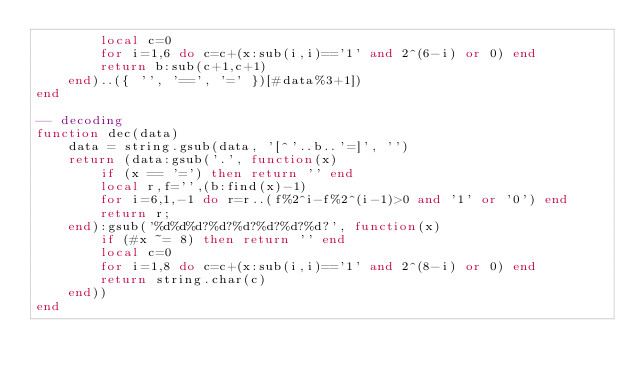<code> <loc_0><loc_0><loc_500><loc_500><_Lua_>        local c=0
        for i=1,6 do c=c+(x:sub(i,i)=='1' and 2^(6-i) or 0) end
        return b:sub(c+1,c+1)
    end)..({ '', '==', '=' })[#data%3+1])
end

-- decoding
function dec(data)
    data = string.gsub(data, '[^'..b..'=]', '')
    return (data:gsub('.', function(x)
        if (x == '=') then return '' end
        local r,f='',(b:find(x)-1)
        for i=6,1,-1 do r=r..(f%2^i-f%2^(i-1)>0 and '1' or '0') end
        return r;
    end):gsub('%d%d%d?%d?%d?%d?%d?%d?', function(x)
        if (#x ~= 8) then return '' end
        local c=0
        for i=1,8 do c=c+(x:sub(i,i)=='1' and 2^(8-i) or 0) end
        return string.char(c)
    end))
end

</code> 